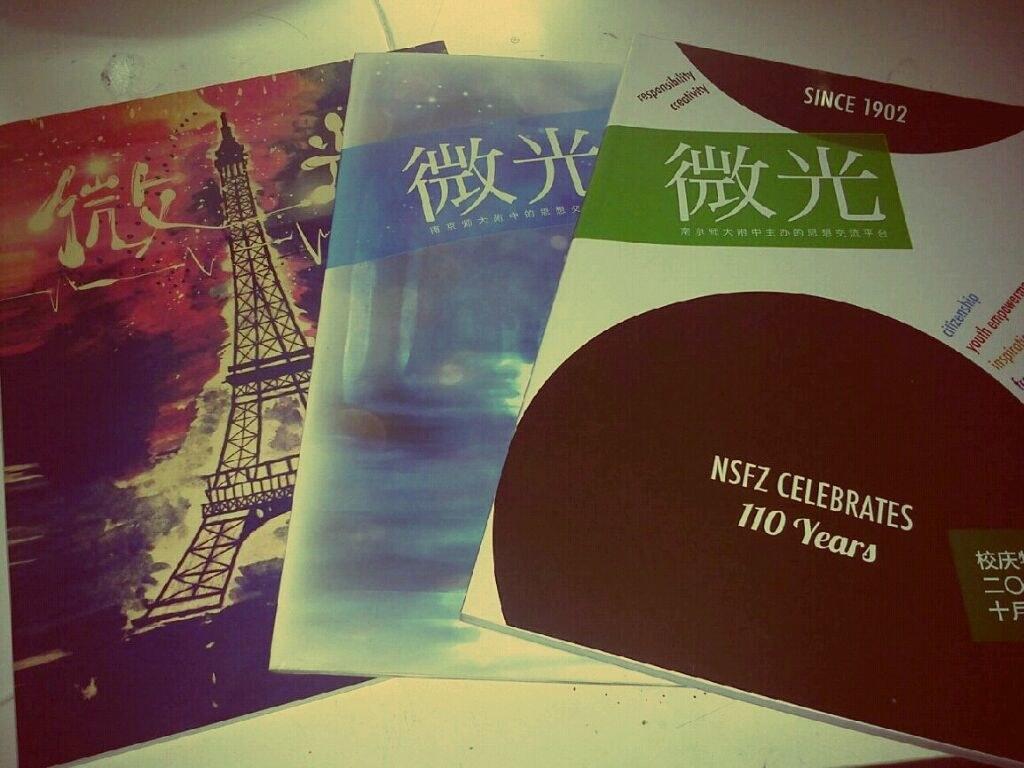How long have they been open?
Keep it short and to the point. 110 years. What year did they open?
Ensure brevity in your answer.  1902. 